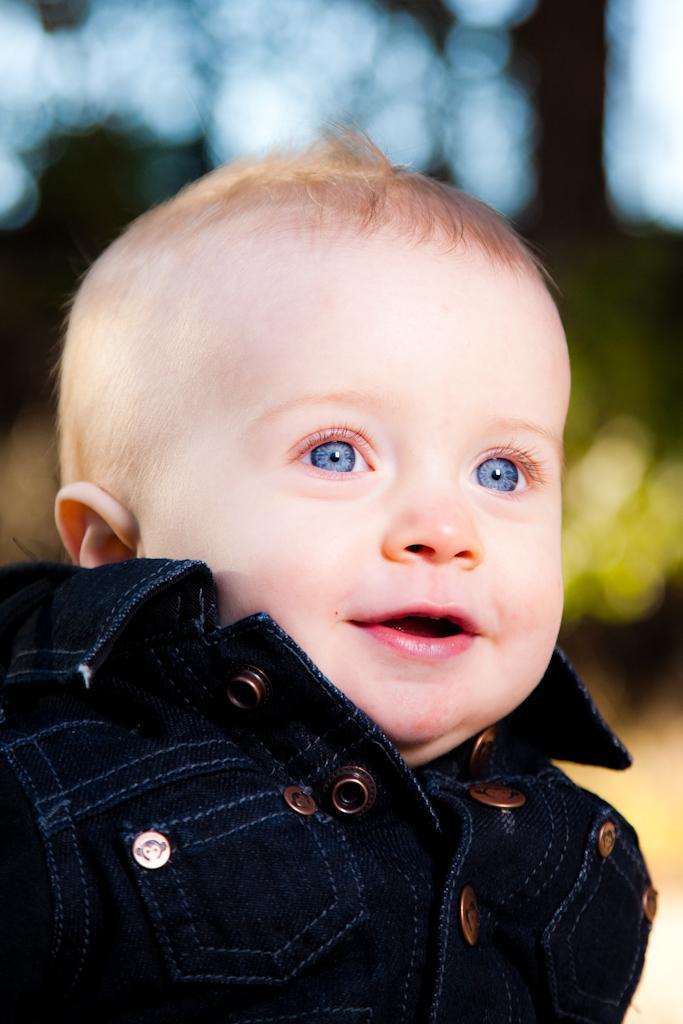Describe this image in one or two sentences. In this image I can see a baby wearing black color dress. Background is blurred. 